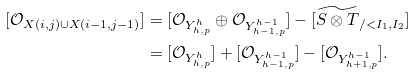<formula> <loc_0><loc_0><loc_500><loc_500>[ \mathcal { O } _ { X ( i , j ) \cup X ( i - 1 , j - 1 ) } ] & = [ \mathcal { O } _ { Y _ { h , p } ^ { h } } \oplus \mathcal { O } _ { Y _ { h - 1 , p } ^ { h - 1 } } ] - [ \widetilde { S \otimes T } _ { / < I _ { 1 } , I _ { 2 } } ] \\ & = [ \mathcal { O } _ { Y _ { h , p } ^ { h } } ] + [ \mathcal { O } _ { Y _ { h - 1 , p } ^ { h - 1 } } ] - [ \mathcal { O } _ { Y _ { h + 1 , p } ^ { h - 1 } } ] .</formula> 